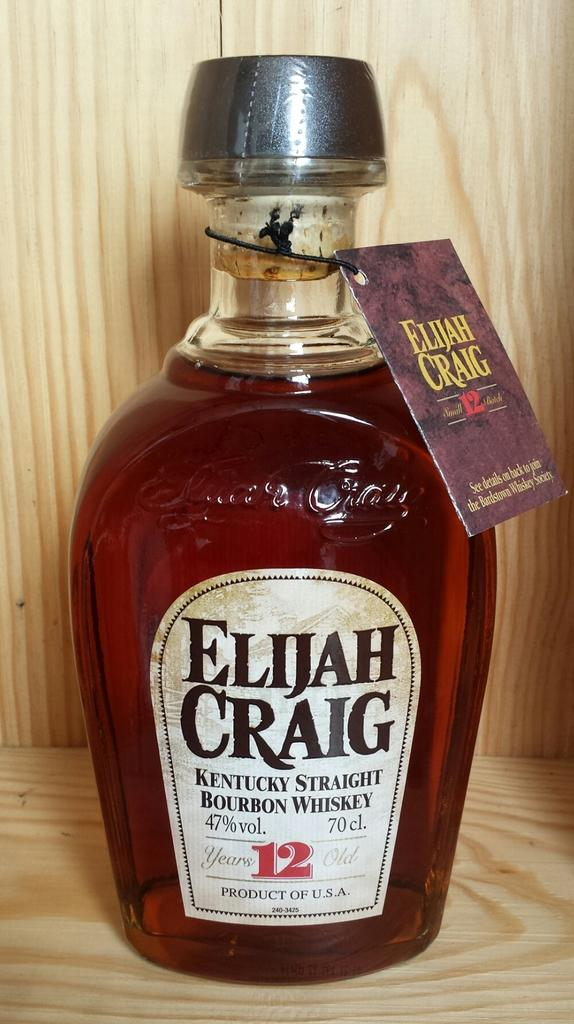<image>
Create a compact narrative representing the image presented. A bottle of Elijah Craig Kentucky Bourbon Whiskey is in a wooden box. 